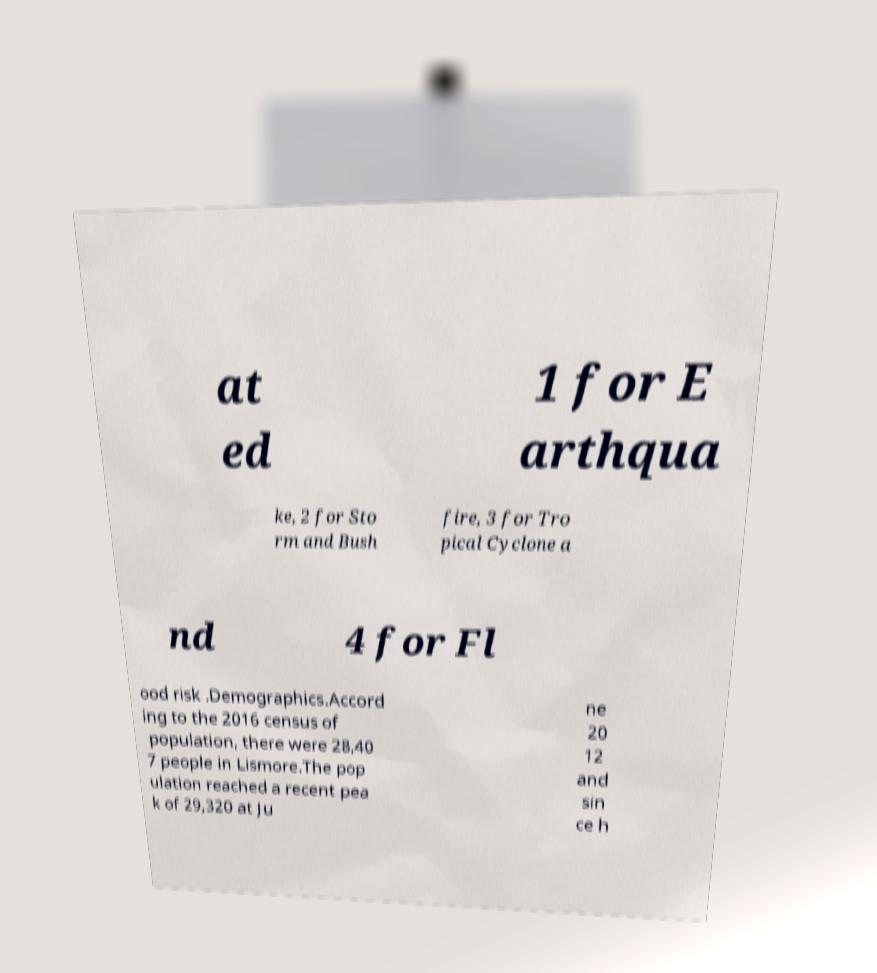For documentation purposes, I need the text within this image transcribed. Could you provide that? at ed 1 for E arthqua ke, 2 for Sto rm and Bush fire, 3 for Tro pical Cyclone a nd 4 for Fl ood risk .Demographics.Accord ing to the 2016 census of population, there were 28,40 7 people in Lismore.The pop ulation reached a recent pea k of 29,320 at Ju ne 20 12 and sin ce h 